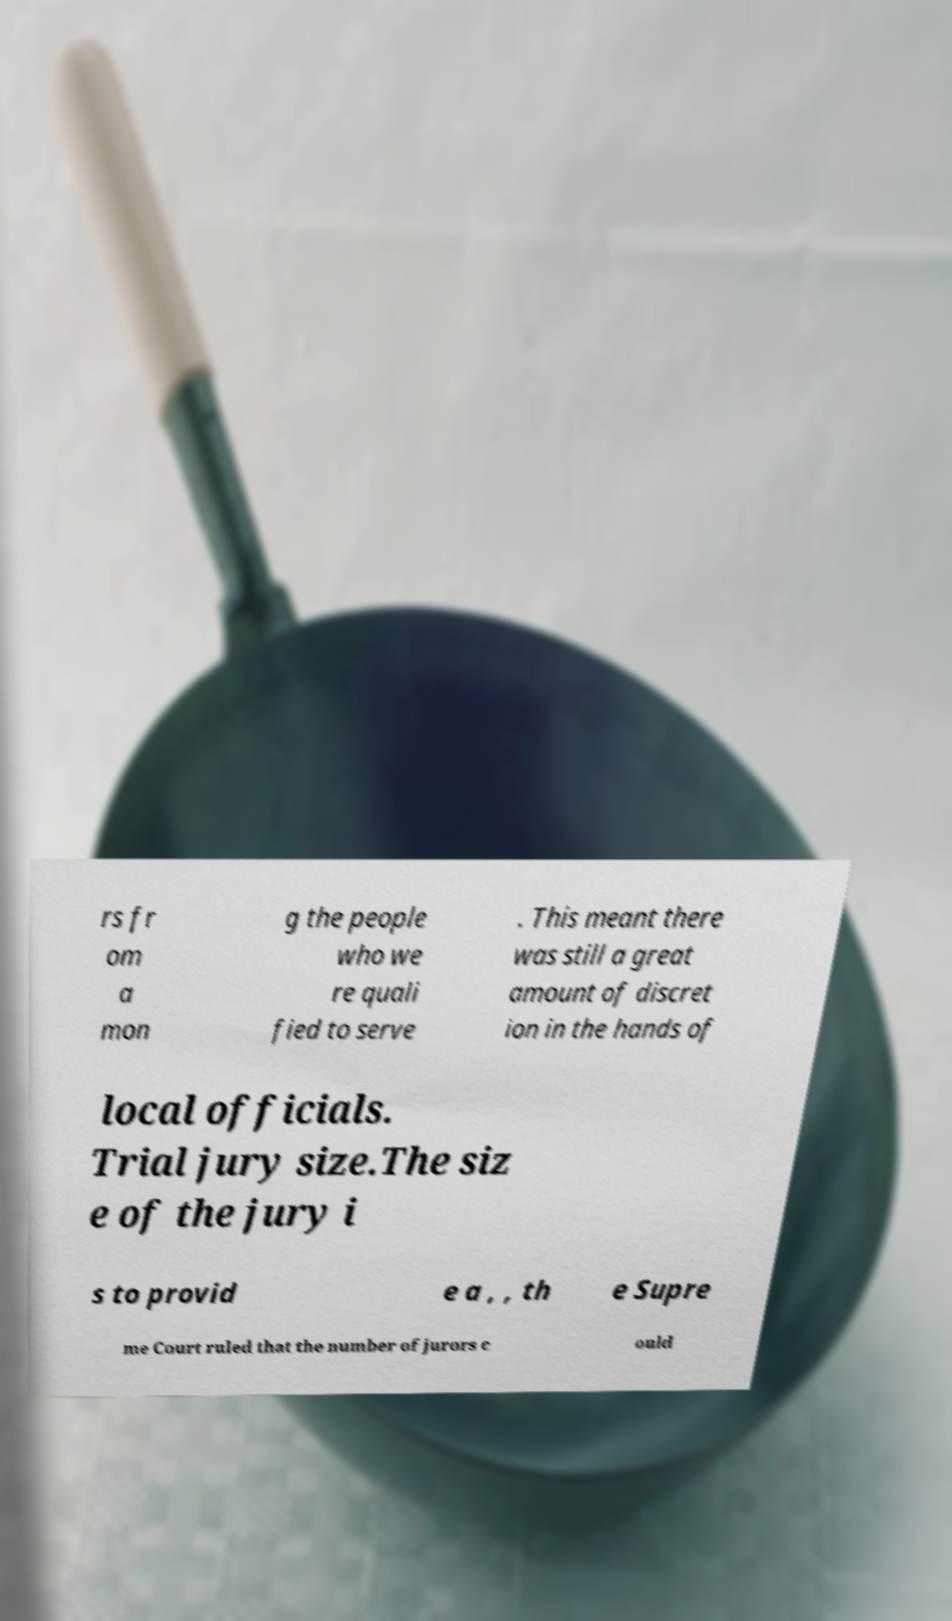I need the written content from this picture converted into text. Can you do that? rs fr om a mon g the people who we re quali fied to serve . This meant there was still a great amount of discret ion in the hands of local officials. Trial jury size.The siz e of the jury i s to provid e a , , th e Supre me Court ruled that the number of jurors c ould 